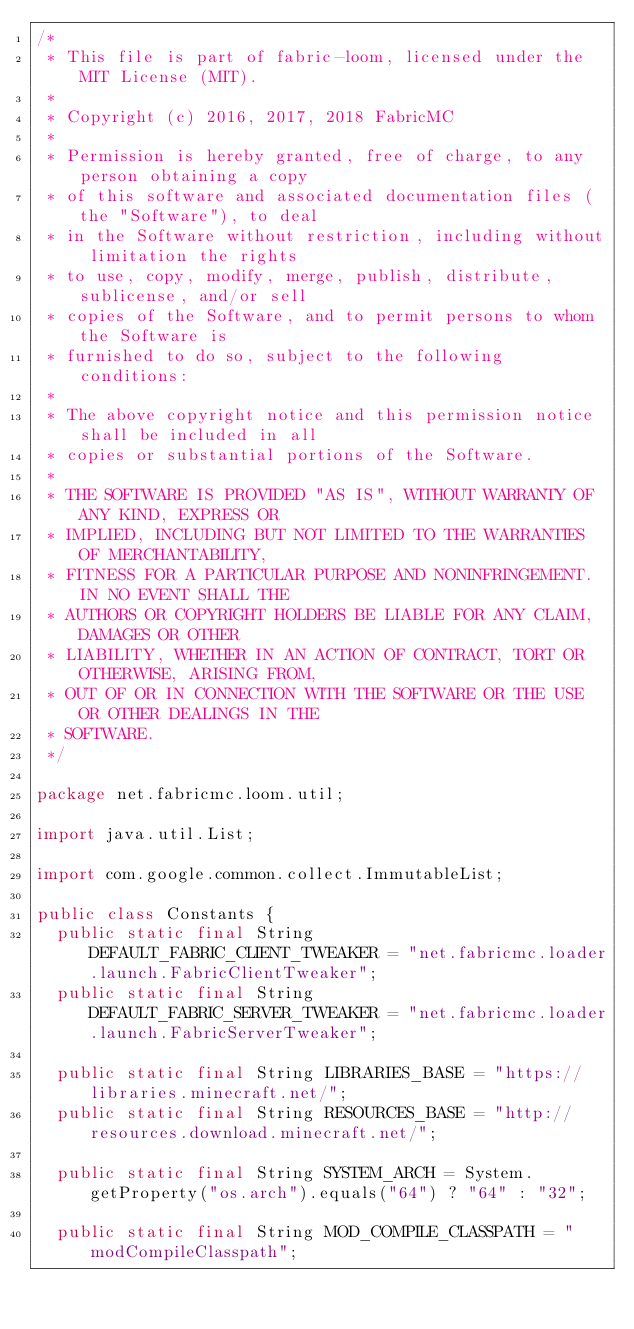Convert code to text. <code><loc_0><loc_0><loc_500><loc_500><_Java_>/*
 * This file is part of fabric-loom, licensed under the MIT License (MIT).
 *
 * Copyright (c) 2016, 2017, 2018 FabricMC
 *
 * Permission is hereby granted, free of charge, to any person obtaining a copy
 * of this software and associated documentation files (the "Software"), to deal
 * in the Software without restriction, including without limitation the rights
 * to use, copy, modify, merge, publish, distribute, sublicense, and/or sell
 * copies of the Software, and to permit persons to whom the Software is
 * furnished to do so, subject to the following conditions:
 *
 * The above copyright notice and this permission notice shall be included in all
 * copies or substantial portions of the Software.
 *
 * THE SOFTWARE IS PROVIDED "AS IS", WITHOUT WARRANTY OF ANY KIND, EXPRESS OR
 * IMPLIED, INCLUDING BUT NOT LIMITED TO THE WARRANTIES OF MERCHANTABILITY,
 * FITNESS FOR A PARTICULAR PURPOSE AND NONINFRINGEMENT. IN NO EVENT SHALL THE
 * AUTHORS OR COPYRIGHT HOLDERS BE LIABLE FOR ANY CLAIM, DAMAGES OR OTHER
 * LIABILITY, WHETHER IN AN ACTION OF CONTRACT, TORT OR OTHERWISE, ARISING FROM,
 * OUT OF OR IN CONNECTION WITH THE SOFTWARE OR THE USE OR OTHER DEALINGS IN THE
 * SOFTWARE.
 */

package net.fabricmc.loom.util;

import java.util.List;

import com.google.common.collect.ImmutableList;

public class Constants {
	public static final String DEFAULT_FABRIC_CLIENT_TWEAKER = "net.fabricmc.loader.launch.FabricClientTweaker";
	public static final String DEFAULT_FABRIC_SERVER_TWEAKER = "net.fabricmc.loader.launch.FabricServerTweaker";

	public static final String LIBRARIES_BASE = "https://libraries.minecraft.net/";
	public static final String RESOURCES_BASE = "http://resources.download.minecraft.net/";

	public static final String SYSTEM_ARCH = System.getProperty("os.arch").equals("64") ? "64" : "32";

	public static final String MOD_COMPILE_CLASSPATH = "modCompileClasspath";</code> 